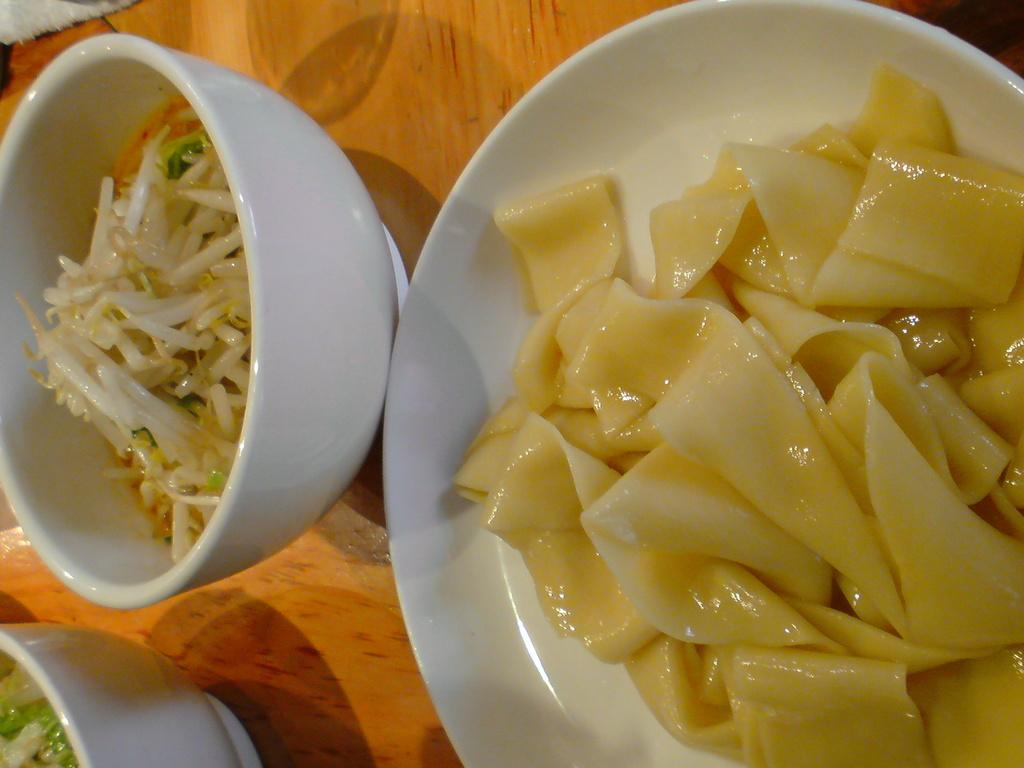What type of dishware is visible in the image? There is a plate and bowls in the image. What is contained within the dishware? There is food in the image. What type of surface is the dishware placed on? The wooden surface is present in the image. What type of punishment is being administered to the self in the image? There is no punishment or self-inflicted action present in the image; it only features a plate, bowls, food, and a wooden surface. 